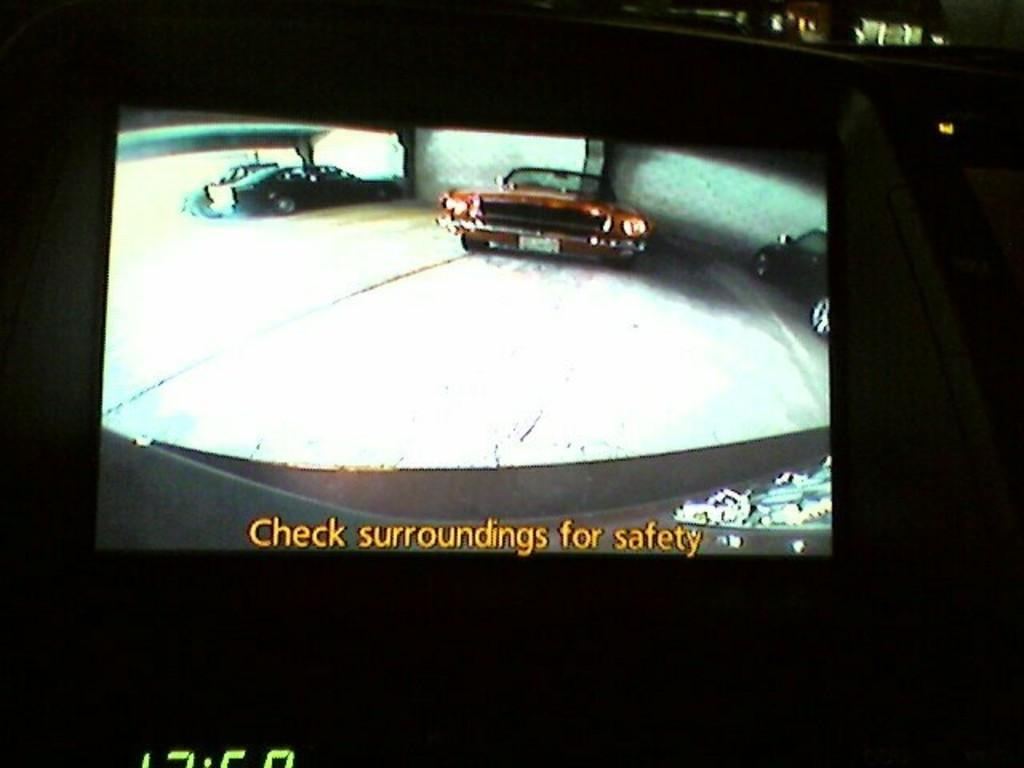What is the main subject of the image? The main subject of the image is a screen. What can be seen on the screen? The screen displays cars on the road. Is there any text present in the image? Yes, there is text at the bottom of the image. What type of soup is being served in the image? There is no soup present in the image; it features a screen displaying cars on the road. Can you tell me who is telling the joke in the image? There is no joke or person telling a joke in the image; it only shows a screen with cars on the road and text at the bottom. 